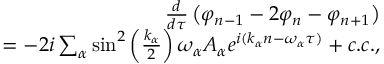Convert formula to latex. <formula><loc_0><loc_0><loc_500><loc_500>\begin{array} { r } { \frac { d } { d \tau } \left ( \varphi _ { n - 1 } - 2 \varphi _ { n } - \varphi _ { n + 1 } \right ) } \\ { = - 2 i \sum _ { \alpha } \sin ^ { 2 } \left ( \frac { k _ { \alpha } } { 2 } \right ) \omega _ { \alpha } A _ { \alpha } e ^ { i ( k _ { \alpha } n - \omega _ { \alpha } \tau ) } + c . c . , } \end{array}</formula> 